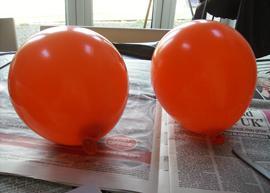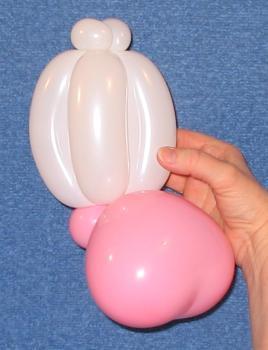The first image is the image on the left, the second image is the image on the right. Analyze the images presented: Is the assertion "An image shows exactly two balloons of different colors, posed horizontally side-by-side." valid? Answer yes or no. No. The first image is the image on the left, the second image is the image on the right. Assess this claim about the two images: "The left image contains at least two red balloons.". Correct or not? Answer yes or no. Yes. 